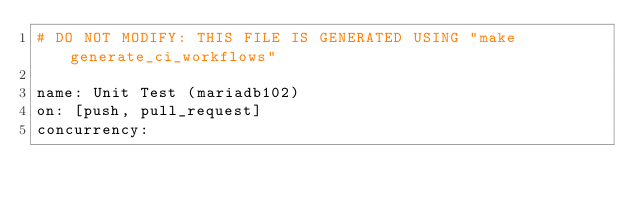Convert code to text. <code><loc_0><loc_0><loc_500><loc_500><_YAML_># DO NOT MODIFY: THIS FILE IS GENERATED USING "make generate_ci_workflows"

name: Unit Test (mariadb102)
on: [push, pull_request]
concurrency:</code> 